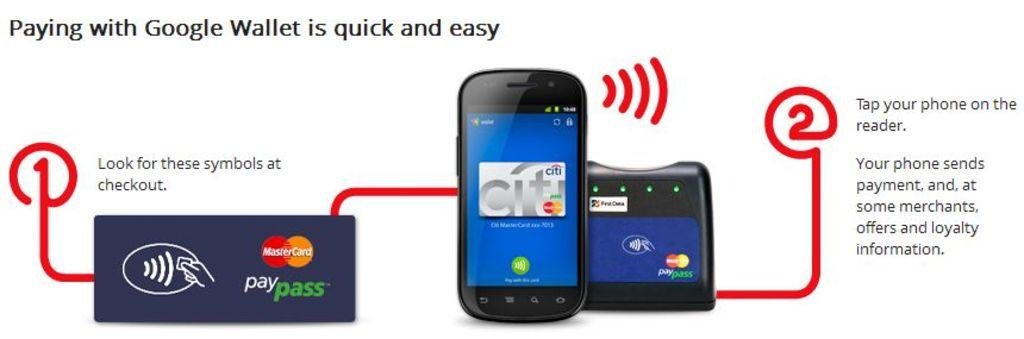What type of image is being described? The image is a screenshot. What is the primary content of the screenshot? There is an advertisement for an application in the image. What color is the shirt being worn by the farmer in the image? There is no farmer or shirt present in the image; it features an advertisement for an application. 